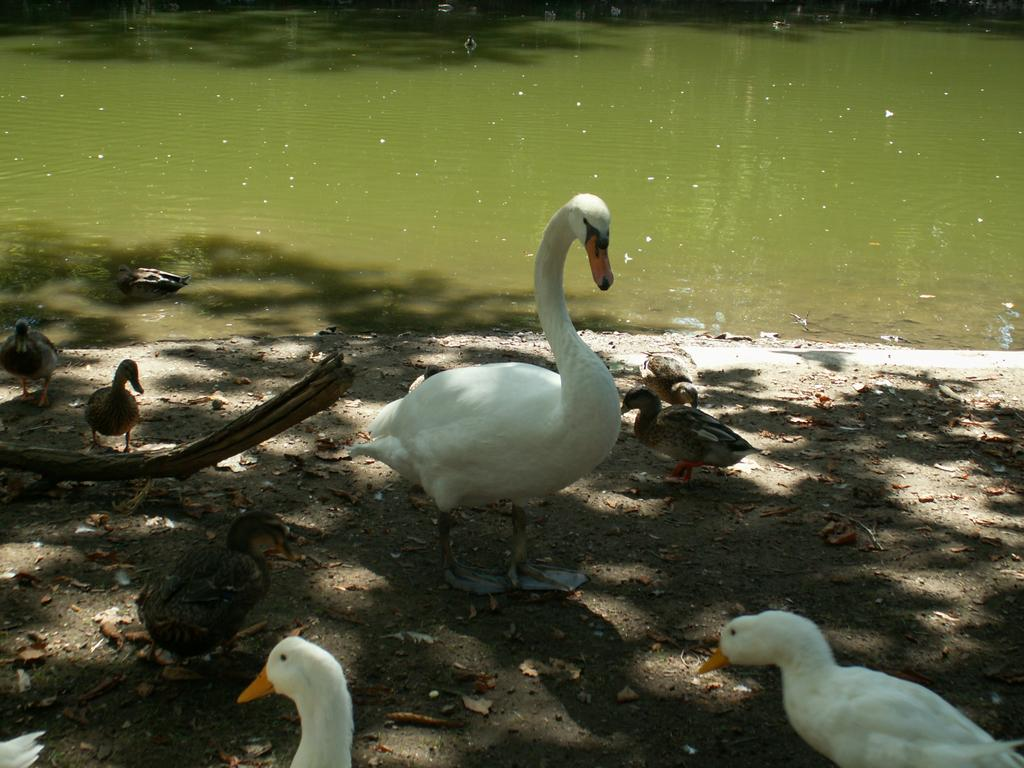What is present in the image that is not solid? There is water visible in the image. What type of animals can be seen in the image? There are ducks and ducklings in the image. Where are the ducks and ducklings located? The ducks and ducklings are on the ground. What type of foot can be seen in the image? There is no foot visible in the image; it features ducks and ducklings on the ground. What level of the building is shown in the image? There is no building present in the image; it features ducks and ducklings on the ground near water. 